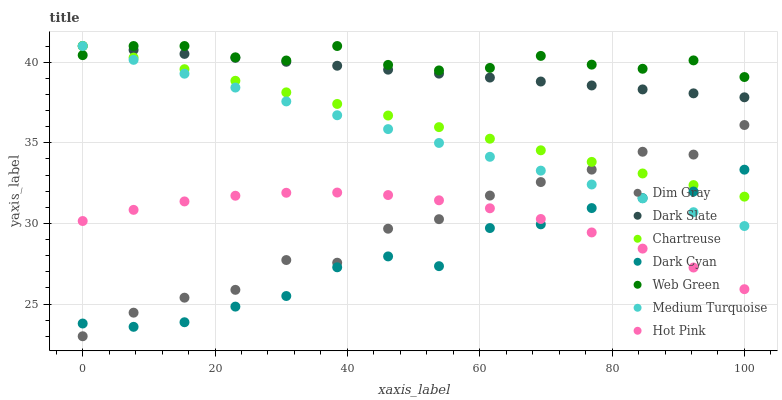Does Dark Cyan have the minimum area under the curve?
Answer yes or no. Yes. Does Web Green have the maximum area under the curve?
Answer yes or no. Yes. Does Hot Pink have the minimum area under the curve?
Answer yes or no. No. Does Hot Pink have the maximum area under the curve?
Answer yes or no. No. Is Chartreuse the smoothest?
Answer yes or no. Yes. Is Dim Gray the roughest?
Answer yes or no. Yes. Is Hot Pink the smoothest?
Answer yes or no. No. Is Hot Pink the roughest?
Answer yes or no. No. Does Dim Gray have the lowest value?
Answer yes or no. Yes. Does Hot Pink have the lowest value?
Answer yes or no. No. Does Medium Turquoise have the highest value?
Answer yes or no. Yes. Does Hot Pink have the highest value?
Answer yes or no. No. Is Dim Gray less than Web Green?
Answer yes or no. Yes. Is Web Green greater than Dark Cyan?
Answer yes or no. Yes. Does Dark Cyan intersect Dim Gray?
Answer yes or no. Yes. Is Dark Cyan less than Dim Gray?
Answer yes or no. No. Is Dark Cyan greater than Dim Gray?
Answer yes or no. No. Does Dim Gray intersect Web Green?
Answer yes or no. No. 